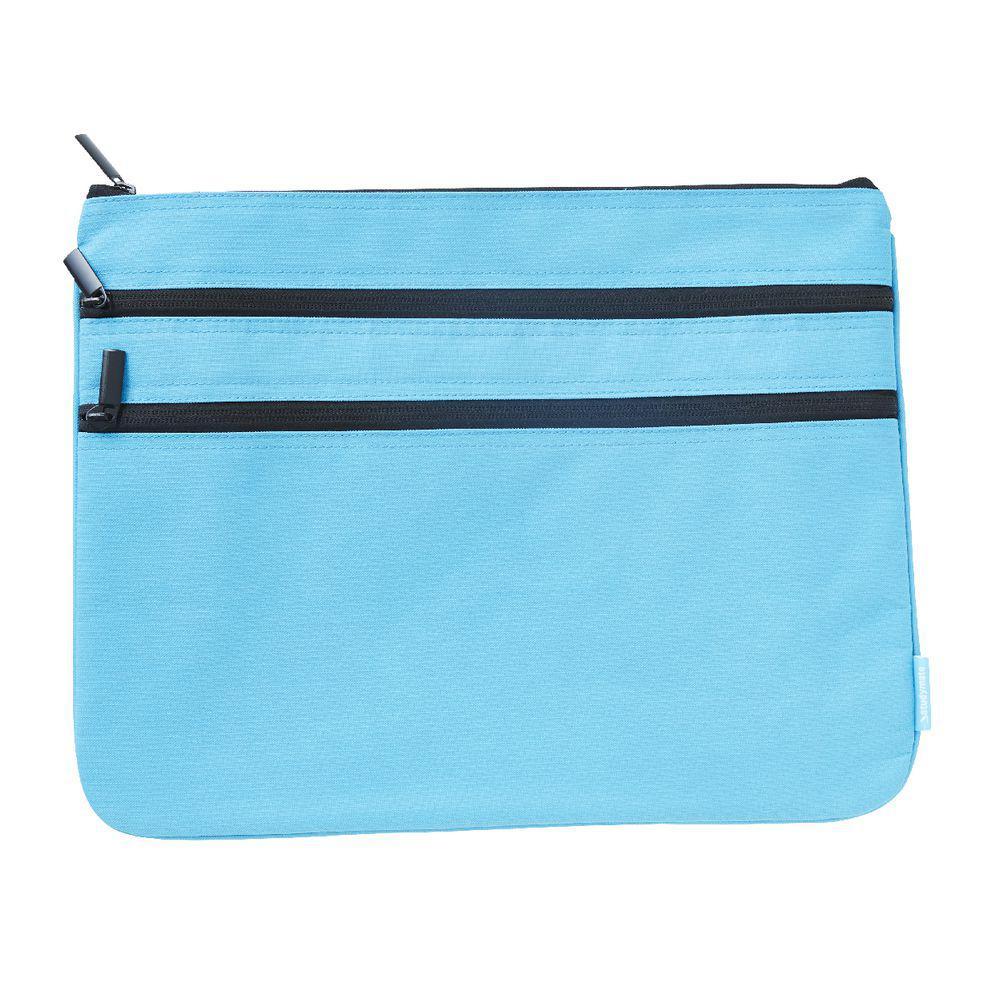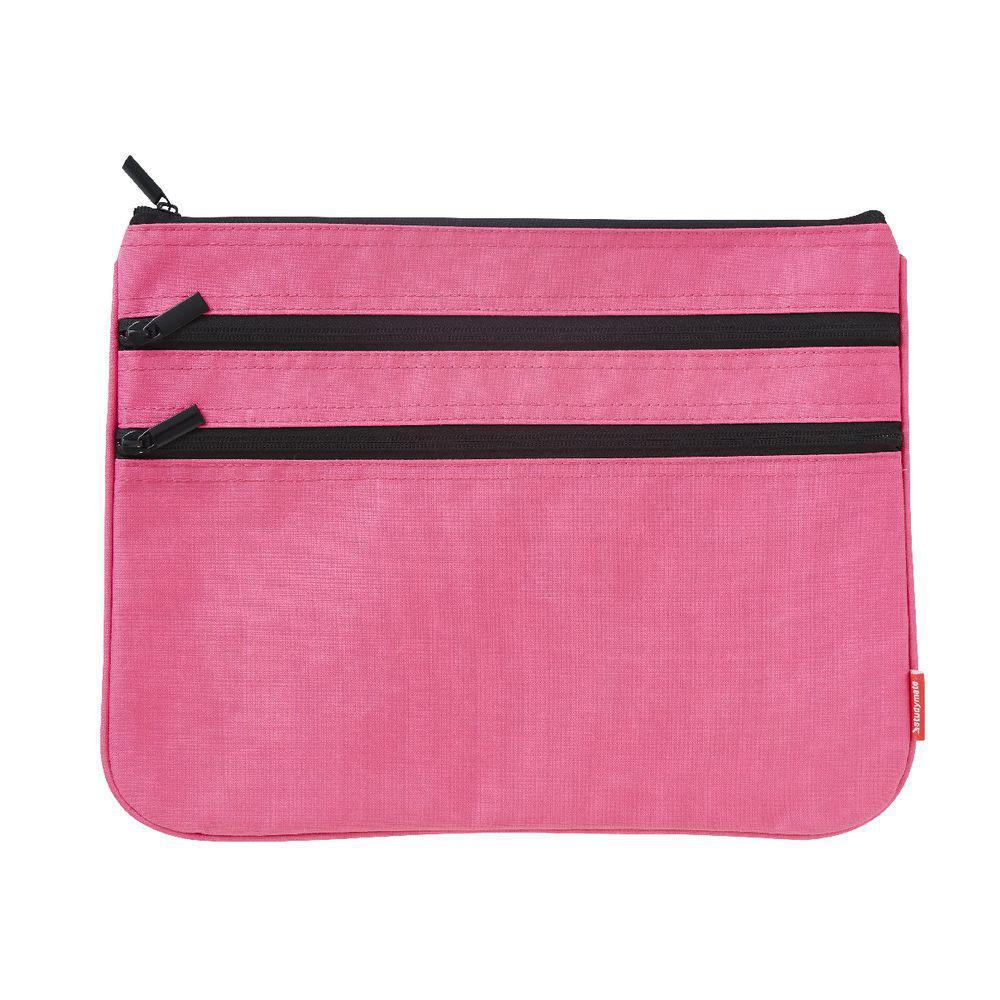The first image is the image on the left, the second image is the image on the right. Examine the images to the left and right. Is the description "Each case has a single zipper and a rectangular shape with non-rounded bottom corners, and one case has a gray card on the front." accurate? Answer yes or no. No. The first image is the image on the left, the second image is the image on the right. For the images shown, is this caption "There is a grey tag on the pencil case in one of the images." true? Answer yes or no. No. 